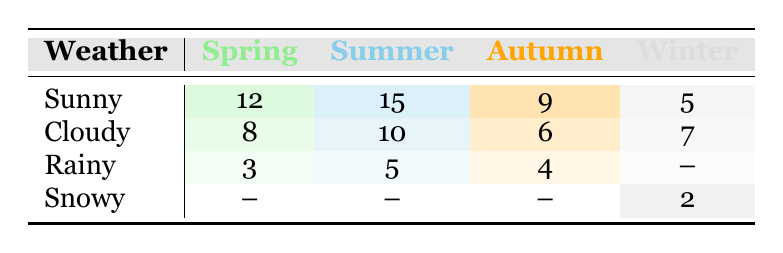What is the frequency of outdoor painting sessions in Summer when it's Sunny? From the table, we look under the Summer column and then the Sunny row. The frequency listed is 15.
Answer: 15 Which season has the lowest frequency of outdoor painting sessions? By examining each season's total frequencies, Spring has 23, Summer has 30, Autumn has 19, and Winter has 14. Winter has the lowest total frequency of 14.
Answer: Winter How many outdoor painting sessions occur during cloudy weather in Autumn? The table specifies under the Autumn column and Cloudy row, indicating a frequency of 6.
Answer: 6 What is the total frequency for outdoor painting sessions during Rainy weather? By summing the frequencies from all seasons: 3 (Spring) + 5 (Summer) + 4 (Autumn) = 12. Winter has no Rainy data, so the total for Rainy weather is 12.
Answer: 12 Is there any frequency recorded for Snowy outdoor painting sessions in Spring? Looking under the Spring column for the Snowy row shows that there are no recorded sessions, indicated by a dash.
Answer: No What is the average frequency of outdoor painting sessions during Sunny weather across all seasons? We add the frequencies: 12 (Spring) + 15 (Summer) + 9 (Autumn) + 5 (Winter) = 41. There are four seasons, so the average is 41 / 4 = 10.25.
Answer: 10.25 Which season has the highest total frequency of outdoor painting sessions? By calculating each season's total: Spring = 23, Summer = 30, Autumn = 19, and Winter = 14, Summer has the highest total frequency of 30.
Answer: Summer What percentage of sessions in Spring are performed on Cloudy days? The total frequency in Spring is 23 (12 Sunny + 8 Cloudy + 3 Rainy). Cloudy sessions are 8. To find the percentage: (8 / 23) * 100 = 34.78%.
Answer: 34.78% During which weather condition in Winter are the outdoor painting sessions the least frequent? Comparing the frequencies in Winter: 5 (Sunny), 7 (Cloudy), and 2 (Snowy), Snowy has the least frequency with 2.
Answer: Snowy 